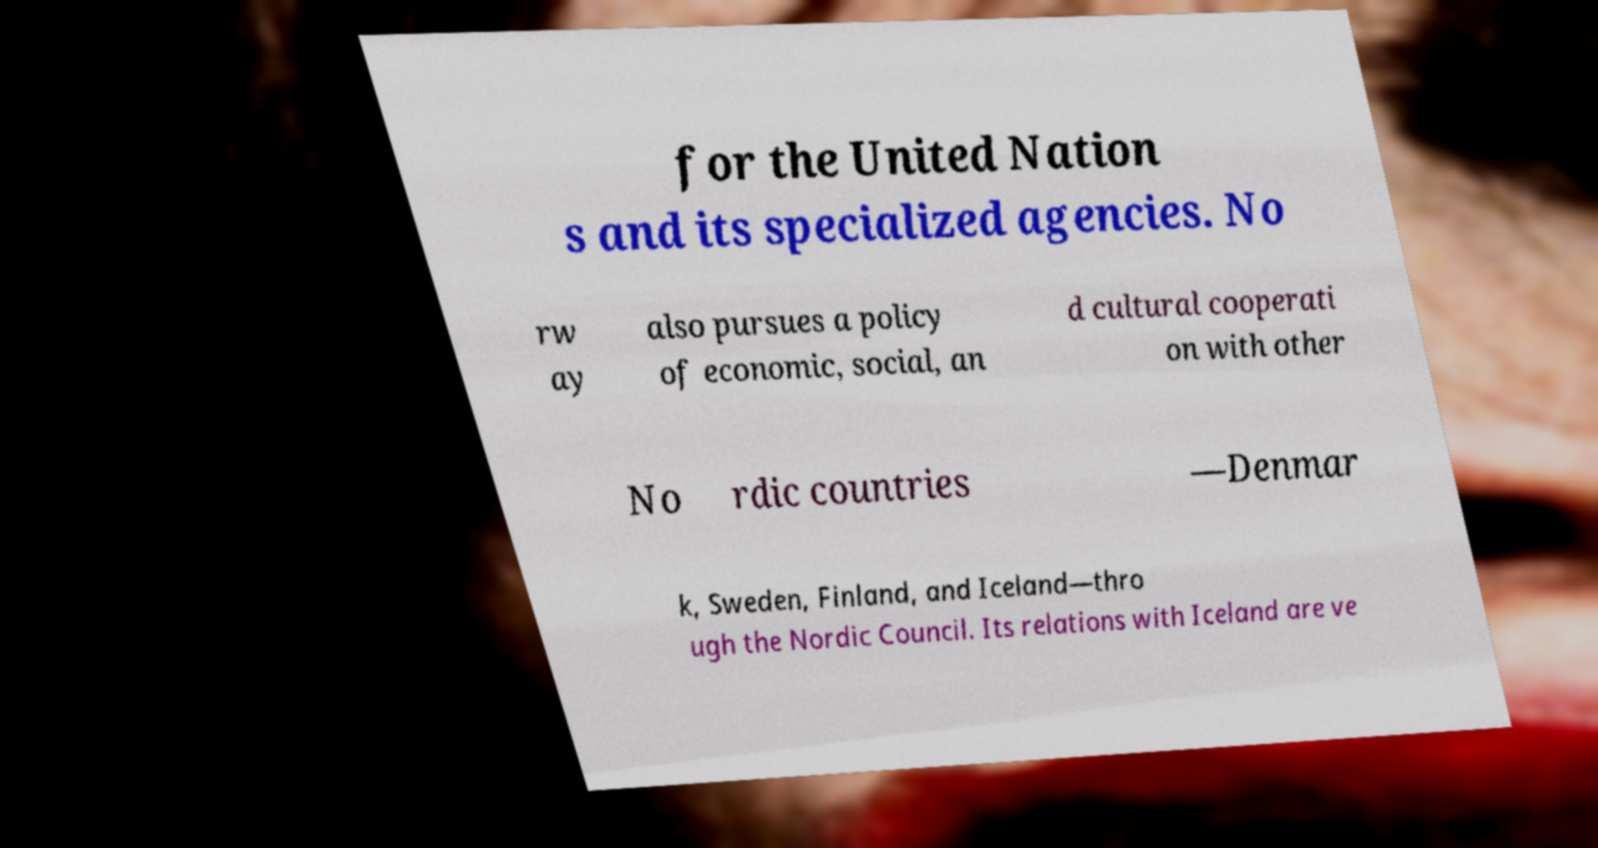Can you accurately transcribe the text from the provided image for me? for the United Nation s and its specialized agencies. No rw ay also pursues a policy of economic, social, an d cultural cooperati on with other No rdic countries —Denmar k, Sweden, Finland, and Iceland—thro ugh the Nordic Council. Its relations with Iceland are ve 